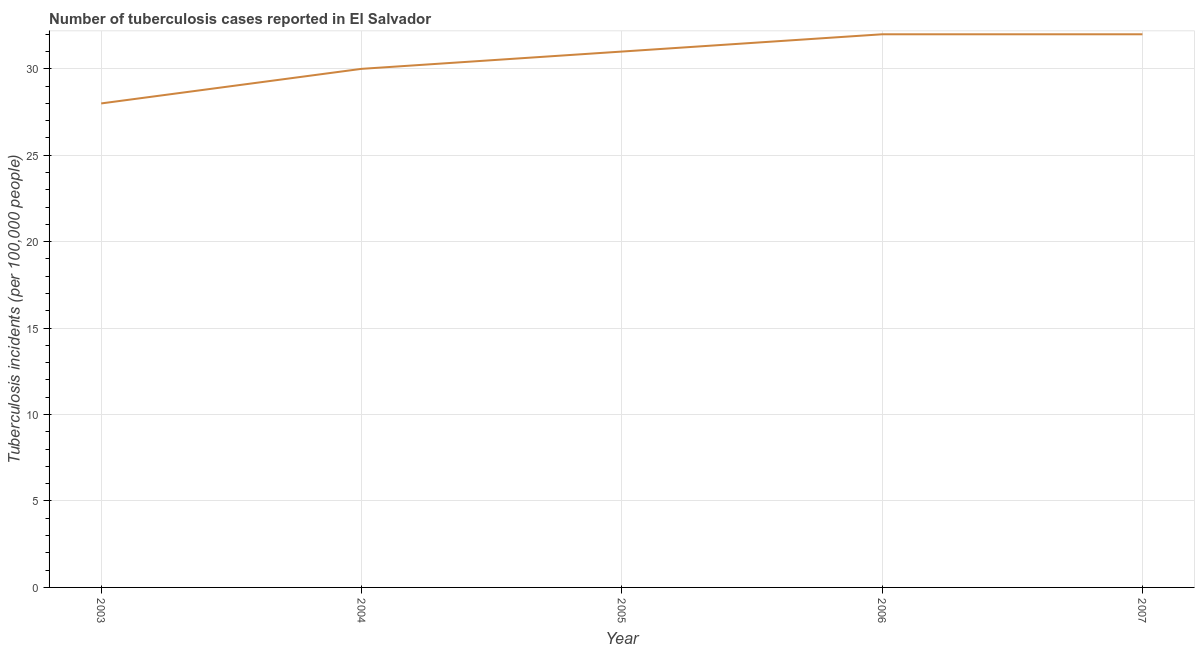What is the number of tuberculosis incidents in 2006?
Make the answer very short. 32. Across all years, what is the maximum number of tuberculosis incidents?
Offer a very short reply. 32. Across all years, what is the minimum number of tuberculosis incidents?
Ensure brevity in your answer.  28. In which year was the number of tuberculosis incidents minimum?
Ensure brevity in your answer.  2003. What is the sum of the number of tuberculosis incidents?
Offer a terse response. 153. What is the difference between the number of tuberculosis incidents in 2003 and 2006?
Offer a very short reply. -4. What is the average number of tuberculosis incidents per year?
Give a very brief answer. 30.6. What is the median number of tuberculosis incidents?
Your answer should be very brief. 31. Do a majority of the years between 2004 and 2007 (inclusive) have number of tuberculosis incidents greater than 12 ?
Give a very brief answer. Yes. What is the ratio of the number of tuberculosis incidents in 2005 to that in 2007?
Provide a short and direct response. 0.97. Is the number of tuberculosis incidents in 2004 less than that in 2005?
Your answer should be very brief. Yes. Is the difference between the number of tuberculosis incidents in 2003 and 2004 greater than the difference between any two years?
Offer a very short reply. No. What is the difference between the highest and the second highest number of tuberculosis incidents?
Offer a terse response. 0. Is the sum of the number of tuberculosis incidents in 2005 and 2006 greater than the maximum number of tuberculosis incidents across all years?
Offer a terse response. Yes. What is the difference between the highest and the lowest number of tuberculosis incidents?
Your answer should be very brief. 4. How many lines are there?
Ensure brevity in your answer.  1. How many years are there in the graph?
Give a very brief answer. 5. What is the difference between two consecutive major ticks on the Y-axis?
Your answer should be very brief. 5. Are the values on the major ticks of Y-axis written in scientific E-notation?
Keep it short and to the point. No. Does the graph contain any zero values?
Your answer should be compact. No. Does the graph contain grids?
Your answer should be very brief. Yes. What is the title of the graph?
Your answer should be very brief. Number of tuberculosis cases reported in El Salvador. What is the label or title of the X-axis?
Offer a very short reply. Year. What is the label or title of the Y-axis?
Your answer should be very brief. Tuberculosis incidents (per 100,0 people). What is the Tuberculosis incidents (per 100,000 people) in 2003?
Make the answer very short. 28. What is the Tuberculosis incidents (per 100,000 people) in 2005?
Provide a succinct answer. 31. What is the difference between the Tuberculosis incidents (per 100,000 people) in 2003 and 2006?
Your answer should be compact. -4. What is the difference between the Tuberculosis incidents (per 100,000 people) in 2004 and 2005?
Offer a very short reply. -1. What is the difference between the Tuberculosis incidents (per 100,000 people) in 2004 and 2007?
Keep it short and to the point. -2. What is the ratio of the Tuberculosis incidents (per 100,000 people) in 2003 to that in 2004?
Give a very brief answer. 0.93. What is the ratio of the Tuberculosis incidents (per 100,000 people) in 2003 to that in 2005?
Offer a terse response. 0.9. What is the ratio of the Tuberculosis incidents (per 100,000 people) in 2003 to that in 2006?
Give a very brief answer. 0.88. What is the ratio of the Tuberculosis incidents (per 100,000 people) in 2003 to that in 2007?
Offer a very short reply. 0.88. What is the ratio of the Tuberculosis incidents (per 100,000 people) in 2004 to that in 2006?
Provide a short and direct response. 0.94. What is the ratio of the Tuberculosis incidents (per 100,000 people) in 2004 to that in 2007?
Ensure brevity in your answer.  0.94. What is the ratio of the Tuberculosis incidents (per 100,000 people) in 2005 to that in 2007?
Ensure brevity in your answer.  0.97. What is the ratio of the Tuberculosis incidents (per 100,000 people) in 2006 to that in 2007?
Your answer should be compact. 1. 